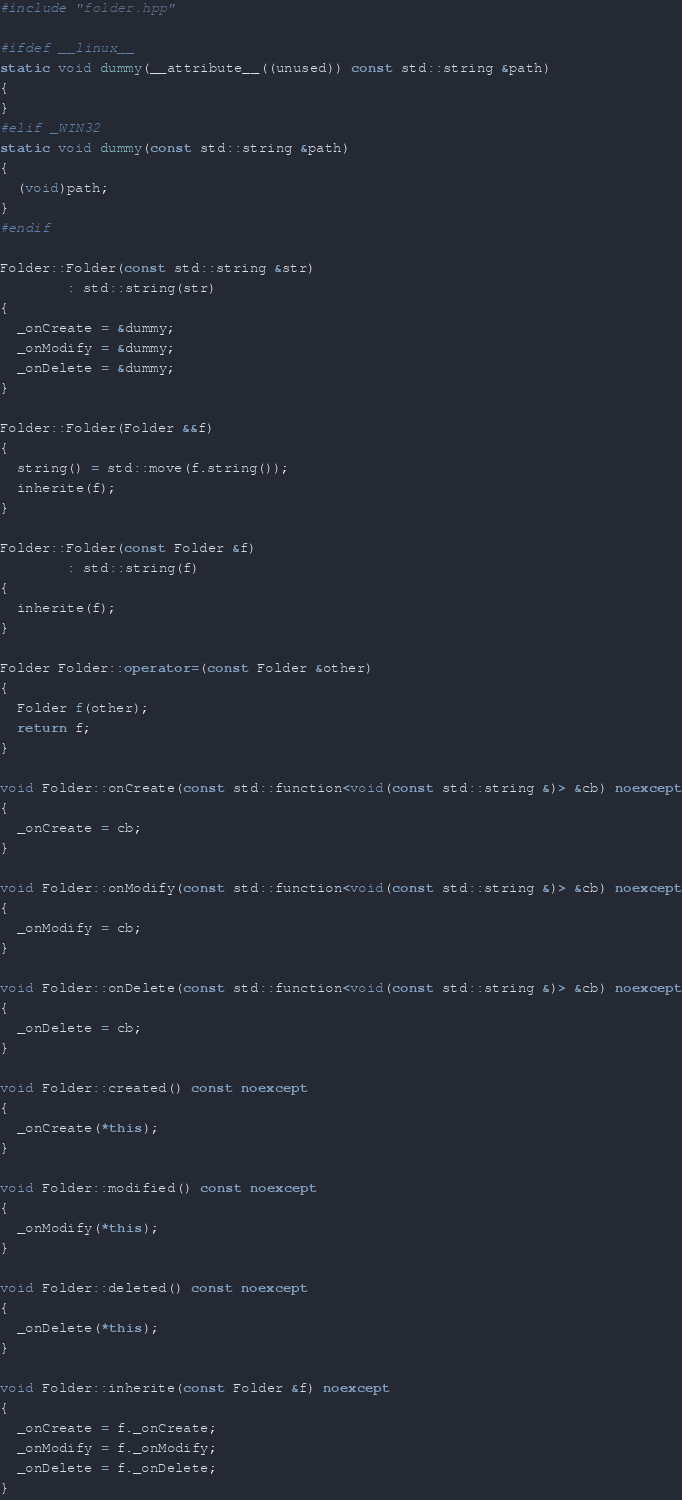Convert code to text. <code><loc_0><loc_0><loc_500><loc_500><_C++_>#include "folder.hpp"

#ifdef __linux__
static void dummy(__attribute__((unused)) const std::string &path)
{
}
#elif _WIN32
static void dummy(const std::string &path)
{
  (void)path;
}
#endif

Folder::Folder(const std::string &str)
        : std::string(str)
{
  _onCreate = &dummy;
  _onModify = &dummy;
  _onDelete = &dummy;
}

Folder::Folder(Folder &&f)
{
  string() = std::move(f.string());
  inherite(f);
}

Folder::Folder(const Folder &f)
        : std::string(f)
{
  inherite(f);
}

Folder Folder::operator=(const Folder &other)
{
  Folder f(other);
  return f;
}

void Folder::onCreate(const std::function<void(const std::string &)> &cb) noexcept
{
  _onCreate = cb;
}

void Folder::onModify(const std::function<void(const std::string &)> &cb) noexcept
{
  _onModify = cb;
}

void Folder::onDelete(const std::function<void(const std::string &)> &cb) noexcept
{
  _onDelete = cb;
}

void Folder::created() const noexcept
{
  _onCreate(*this);
}

void Folder::modified() const noexcept
{
  _onModify(*this);
}

void Folder::deleted() const noexcept
{
  _onDelete(*this);
}

void Folder::inherite(const Folder &f) noexcept
{
  _onCreate = f._onCreate;
  _onModify = f._onModify;
  _onDelete = f._onDelete;
}</code> 